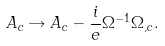<formula> <loc_0><loc_0><loc_500><loc_500>A _ { c } \rightarrow A _ { c } - \frac { i } { e } \Omega ^ { - 1 } \Omega _ { , c } .</formula> 